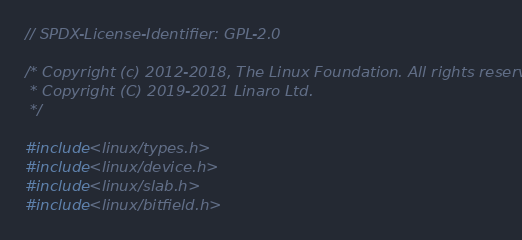Convert code to text. <code><loc_0><loc_0><loc_500><loc_500><_C_>// SPDX-License-Identifier: GPL-2.0

/* Copyright (c) 2012-2018, The Linux Foundation. All rights reserved.
 * Copyright (C) 2019-2021 Linaro Ltd.
 */

#include <linux/types.h>
#include <linux/device.h>
#include <linux/slab.h>
#include <linux/bitfield.h></code> 